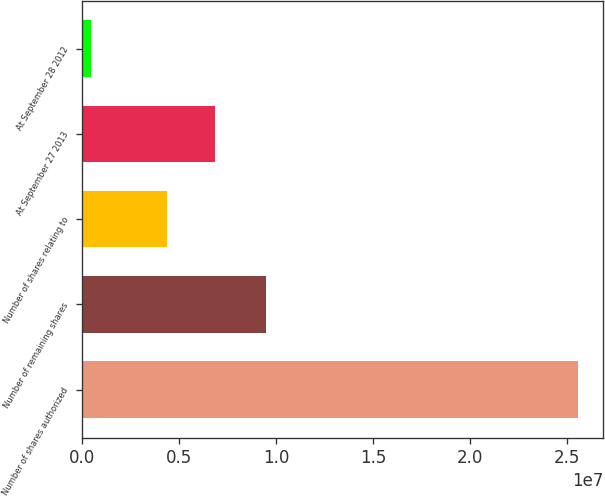<chart> <loc_0><loc_0><loc_500><loc_500><bar_chart><fcel>Number of shares authorized<fcel>Number of remaining shares<fcel>Number of shares relating to<fcel>At September 27 2013<fcel>At September 28 2012<nl><fcel>2.56e+07<fcel>9.45634e+06<fcel>4.35671e+06<fcel>6.87201e+06<fcel>446994<nl></chart> 